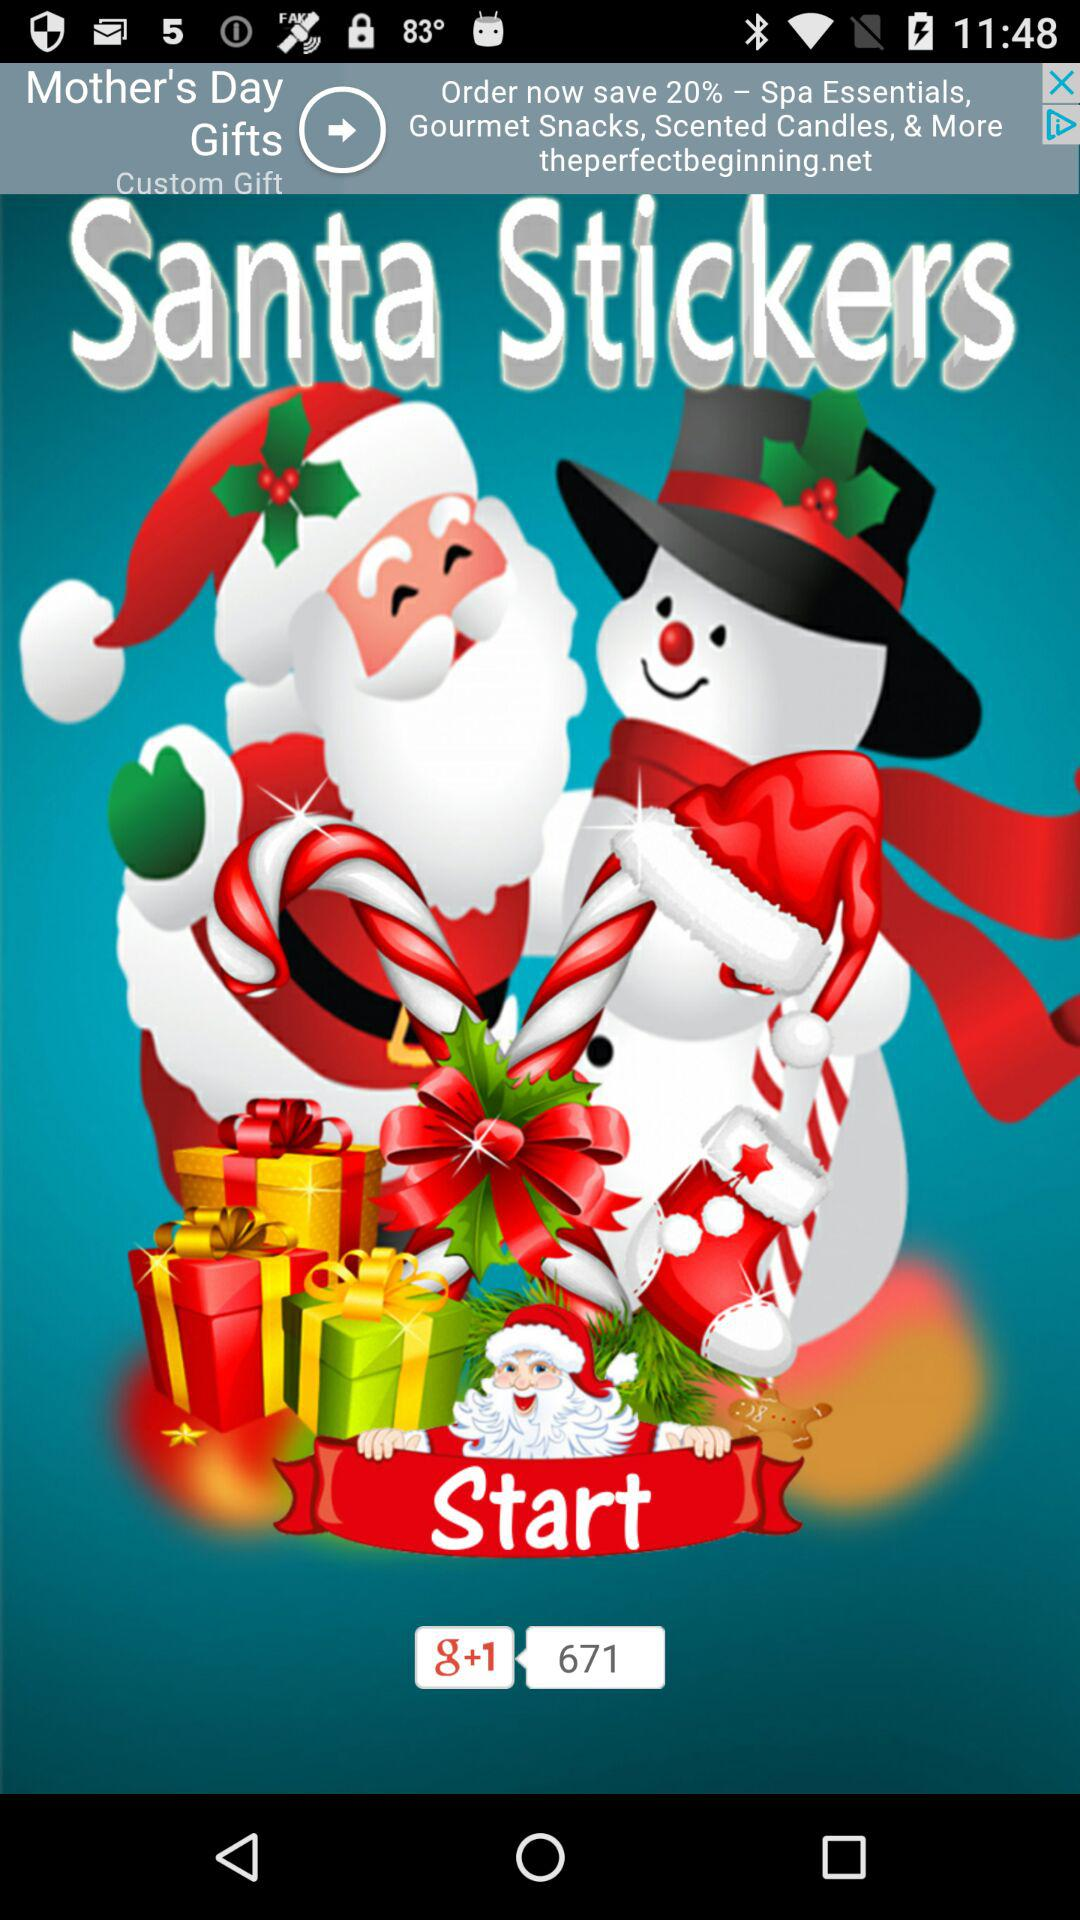What is the name of the application? The name of the application is "Santa Stickers". 